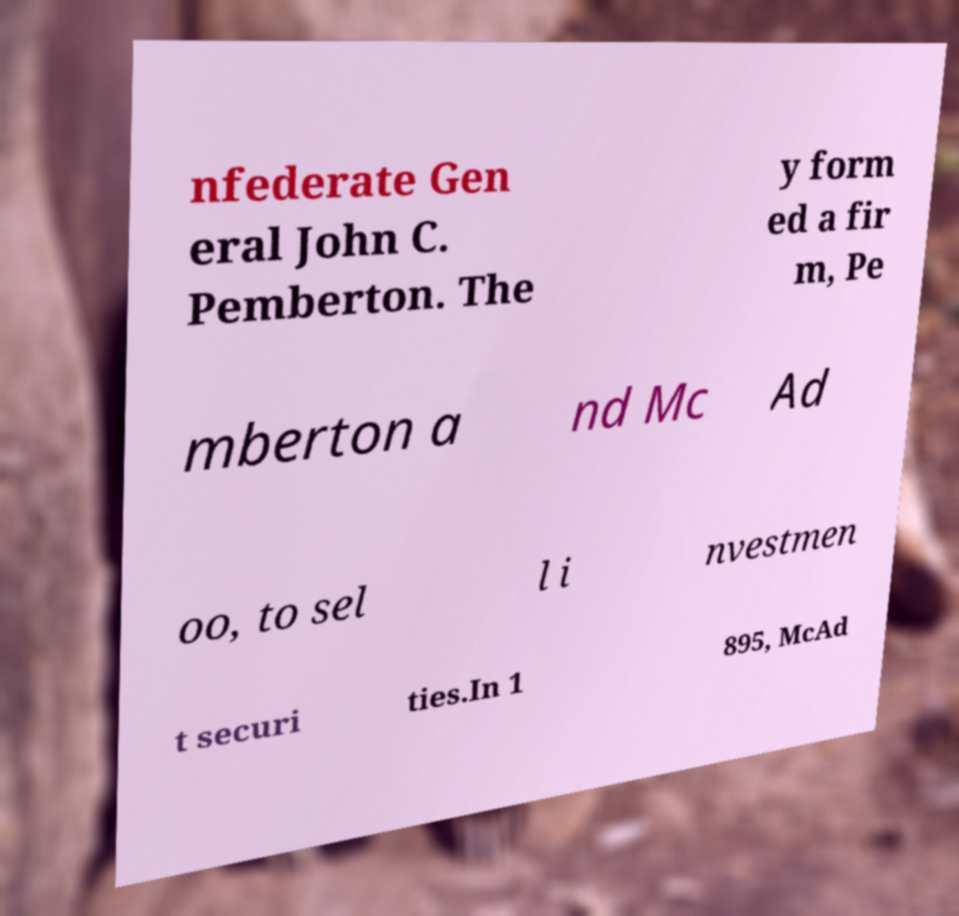I need the written content from this picture converted into text. Can you do that? nfederate Gen eral John C. Pemberton. The y form ed a fir m, Pe mberton a nd Mc Ad oo, to sel l i nvestmen t securi ties.In 1 895, McAd 